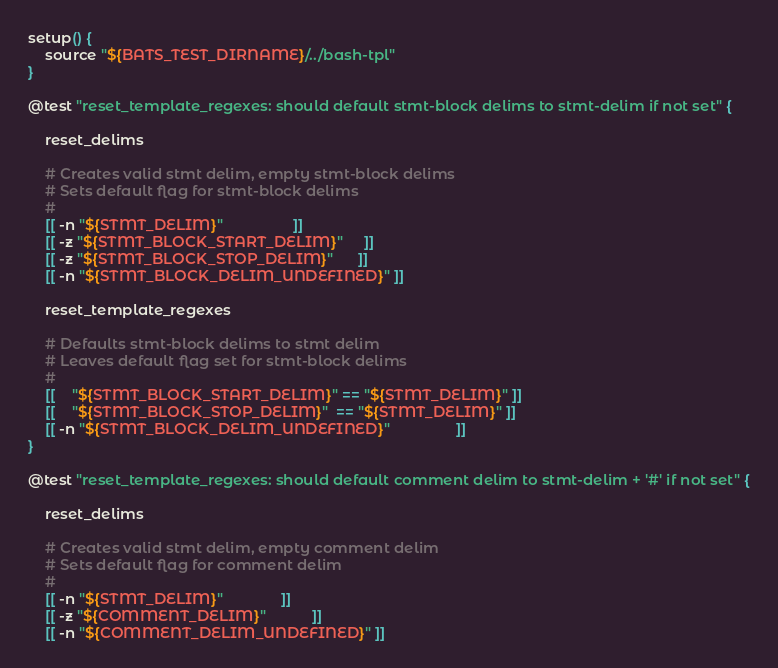Convert code to text. <code><loc_0><loc_0><loc_500><loc_500><_Bash_>
setup() {
	source "${BATS_TEST_DIRNAME}/../bash-tpl"
}

@test "reset_template_regexes: should default stmt-block delims to stmt-delim if not set" {

	reset_delims

	# Creates valid stmt delim, empty stmt-block delims
	# Sets default flag for stmt-block delims
	#
	[[ -n "${STMT_DELIM}"                 ]]
	[[ -z "${STMT_BLOCK_START_DELIM}"     ]]
	[[ -z "${STMT_BLOCK_STOP_DELIM}"      ]]
	[[ -n "${STMT_BLOCK_DELIM_UNDEFINED}" ]]

	reset_template_regexes

	# Defaults stmt-block delims to stmt delim
	# Leaves default flag set for stmt-block delims
	#
	[[    "${STMT_BLOCK_START_DELIM}" == "${STMT_DELIM}" ]]
	[[    "${STMT_BLOCK_STOP_DELIM}"  == "${STMT_DELIM}" ]]
	[[ -n "${STMT_BLOCK_DELIM_UNDEFINED}"                ]]
}

@test "reset_template_regexes: should default comment delim to stmt-delim + '#' if not set" {

	reset_delims

	# Creates valid stmt delim, empty comment delim
	# Sets default flag for comment delim
	#
	[[ -n "${STMT_DELIM}"              ]]
	[[ -z "${COMMENT_DELIM}"           ]]
	[[ -n "${COMMENT_DELIM_UNDEFINED}" ]]
</code> 